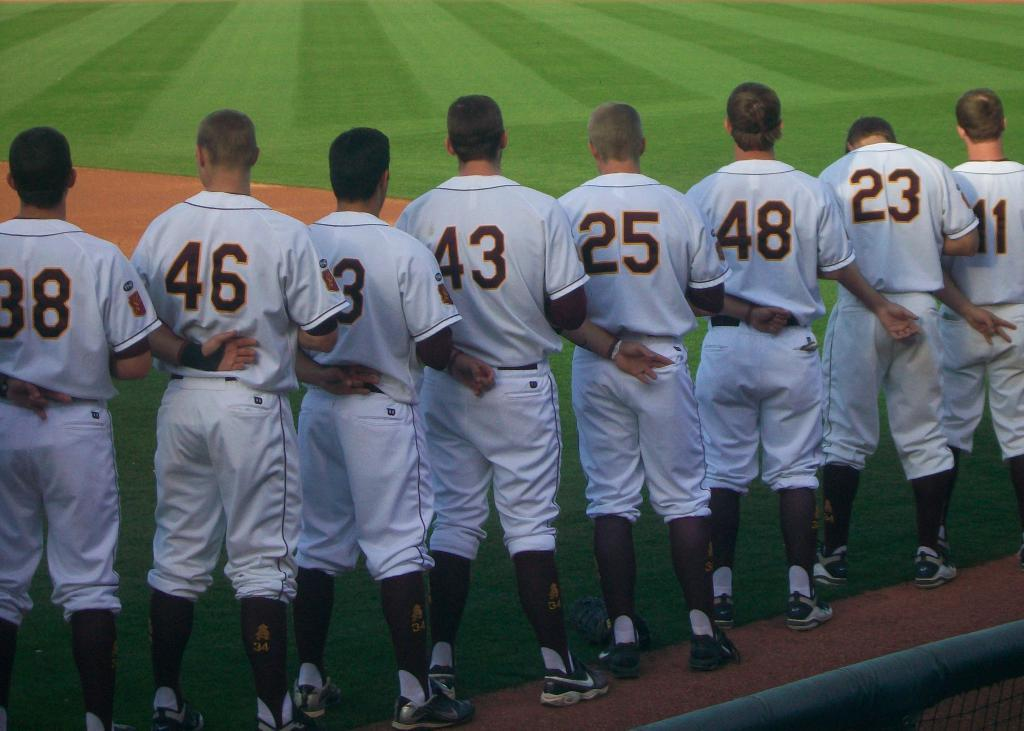How many boys are in the image? There are boys in the image, but the exact number is not specified. What are the boys doing in the image? The boys are standing in series in the center of the image. What type of surface are the boys standing on? There is grassland on the floor in the image. What type of thread is being used by the boys to plough the grassland in the image? There is no thread or ploughing activity present in the image. The boys are simply standing on the grassland. 